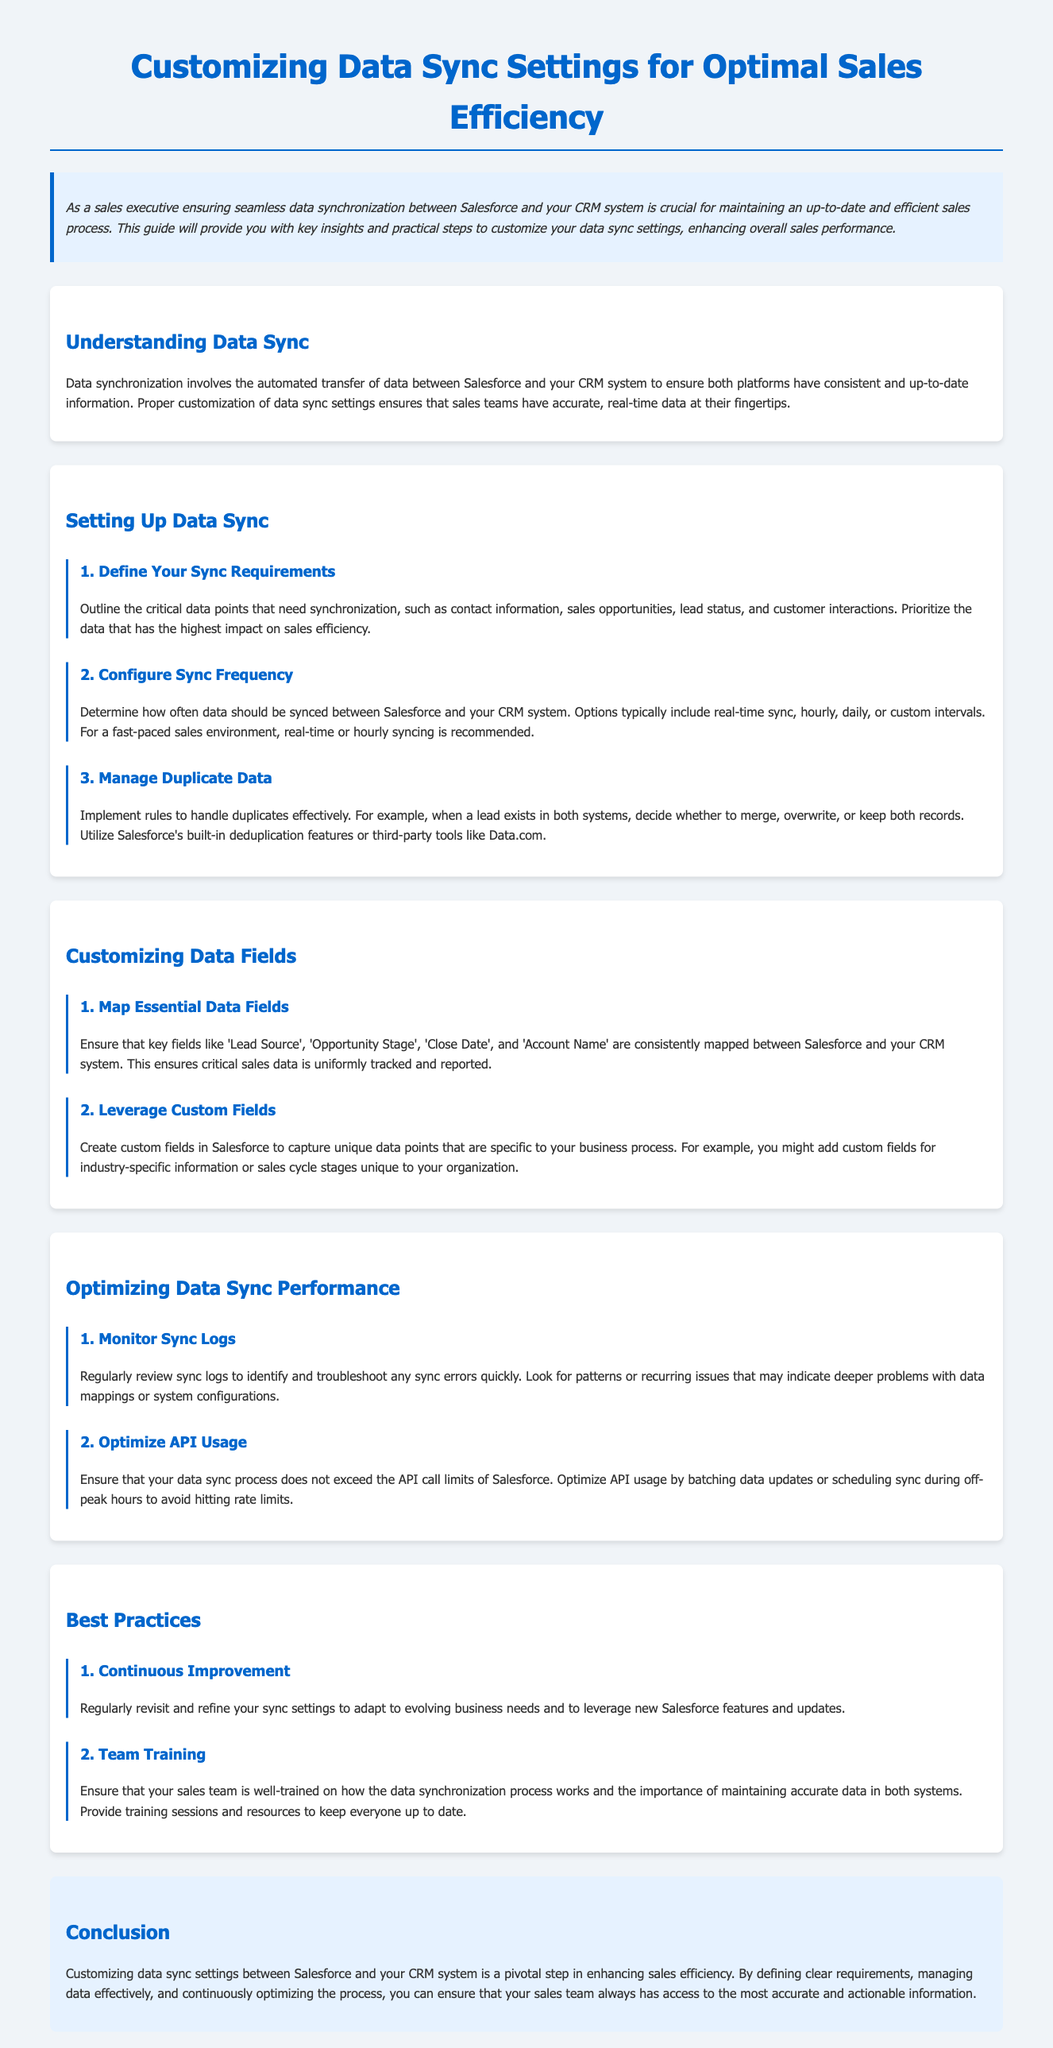What is the title of the document? The title is presented at the top of the document in a large font, which clearly identifies the content focus.
Answer: Customizing Data Sync Settings for Optimal Sales Efficiency What is the purpose of the guide? The purpose is described in the introduction, outlining the importance of the content for sales executives.
Answer: Ensuring seamless data synchronization between Salesforce and CRM How many main sections are there in the document? The document is structured into distinct sections, with each section focusing on a different aspect of data sync.
Answer: Five What is recommended sync frequency for a fast-paced sales environment? This information is found under the configuration of sync frequency in the setting up section.
Answer: Real-time or hourly Which critical data point is specifically mentioned for synchronization? The guide lists various critical data points that should be synchronized; one of these is clearly mentioned.
Answer: Contact information What is one method to handle duplicate data? The document outlines strategies to manage duplicates effectively, providing specific options for what to do.
Answer: Merge, overwrite, or keep both records What is advised to be regularly reviewed for optimizing data sync performance? This detail pertains to the performance monitoring of the sync process and is mentioned in a specific section.
Answer: Sync logs What should be optimized to avoid exceeding API call limits? The guide discusses best practices for maintaining efficiency in the data sync process, highlighting a specific focus area.
Answer: API usage How often should sync settings be revisited? This is part of the best practices provided in the document, suggesting a frequency of review for effectiveness.
Answer: Regularly 